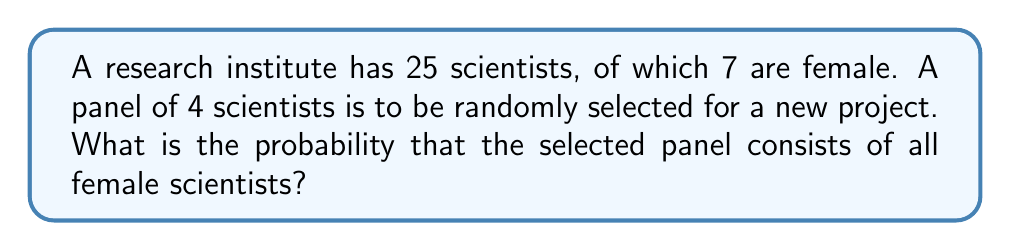Can you answer this question? Let's approach this step-by-step:

1) First, we need to calculate the number of ways to select 4 female scientists from the 7 available. This is a combination problem, denoted as $\binom{7}{4}$ or $C(7,4)$.

   $$\binom{7}{4} = \frac{7!}{4!(7-4)!} = \frac{7!}{4!3!} = 35$$

2) Next, we need to calculate the total number of ways to select any 4 scientists from the 25 available. This is denoted as $\binom{25}{4}$ or $C(25,4)$.

   $$\binom{25}{4} = \frac{25!}{4!(25-4)!} = \frac{25!}{4!21!} = 12650$$

3) The probability is then the number of favorable outcomes divided by the total number of possible outcomes:

   $$P(\text{all-female panel}) = \frac{\text{number of all-female panels}}{\text{total number of possible panels}} = \frac{\binom{7}{4}}{\binom{25}{4}}$$

4) Substituting the values we calculated:

   $$P(\text{all-female panel}) = \frac{35}{12650} = \frac{7}{2530} \approx 0.00277$$
Answer: $\frac{7}{2530}$ or approximately 0.00277 